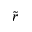Convert formula to latex. <formula><loc_0><loc_0><loc_500><loc_500>\widetilde { r }</formula> 